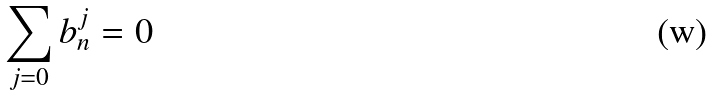<formula> <loc_0><loc_0><loc_500><loc_500>\sum _ { j = 0 } b _ { n } ^ { j } = 0</formula> 